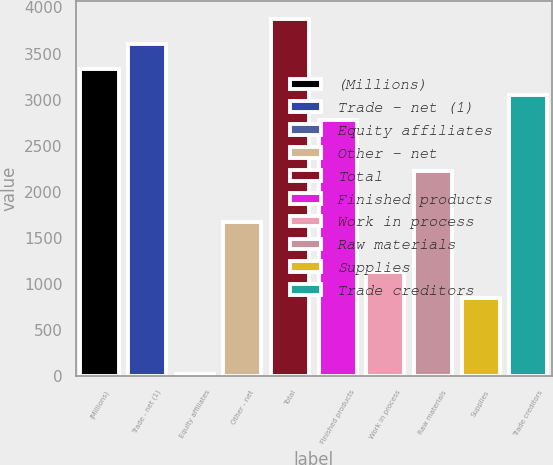Convert chart. <chart><loc_0><loc_0><loc_500><loc_500><bar_chart><fcel>(Millions)<fcel>Trade - net (1)<fcel>Equity affiliates<fcel>Other - net<fcel>Total<fcel>Finished products<fcel>Work in process<fcel>Raw materials<fcel>Supplies<fcel>Trade creditors<nl><fcel>3328.8<fcel>3604.2<fcel>24<fcel>1676.4<fcel>3879.6<fcel>2778<fcel>1125.6<fcel>2227.2<fcel>850.2<fcel>3053.4<nl></chart> 